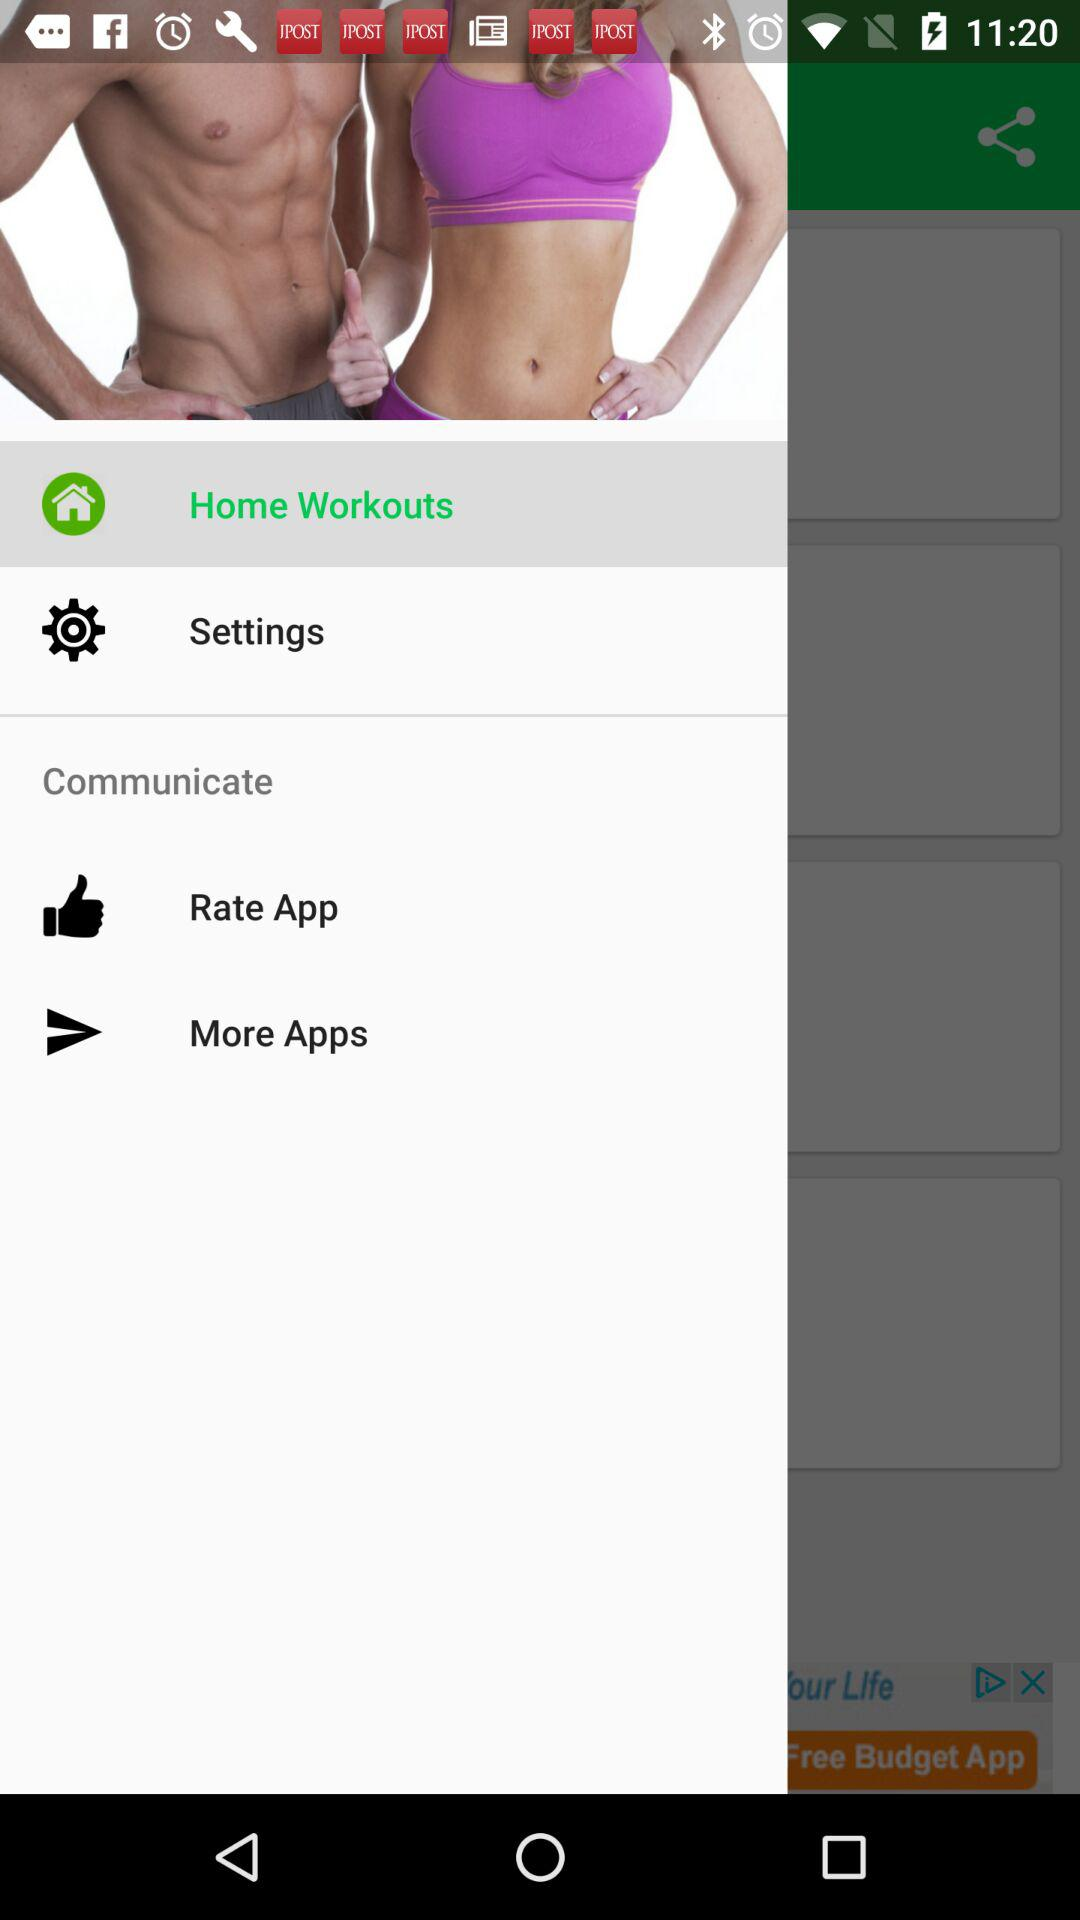Which rating did the application receive?
When the provided information is insufficient, respond with <no answer>. <no answer> 